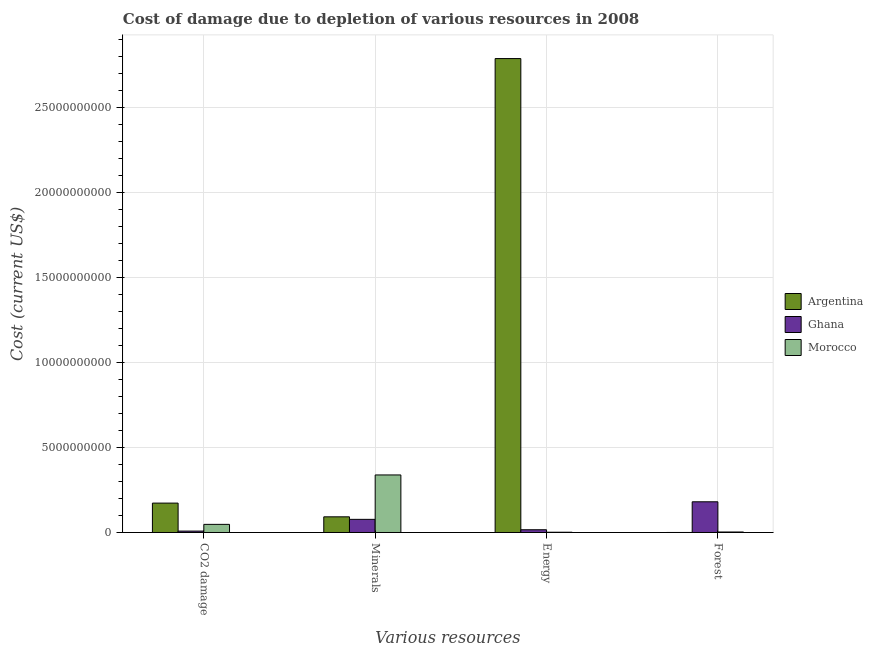How many different coloured bars are there?
Your answer should be very brief. 3. How many groups of bars are there?
Give a very brief answer. 4. Are the number of bars per tick equal to the number of legend labels?
Provide a short and direct response. Yes. How many bars are there on the 4th tick from the right?
Your answer should be very brief. 3. What is the label of the 2nd group of bars from the left?
Offer a terse response. Minerals. What is the cost of damage due to depletion of forests in Ghana?
Provide a short and direct response. 1.81e+09. Across all countries, what is the maximum cost of damage due to depletion of minerals?
Ensure brevity in your answer.  3.38e+09. Across all countries, what is the minimum cost of damage due to depletion of coal?
Ensure brevity in your answer.  8.25e+07. In which country was the cost of damage due to depletion of minerals maximum?
Keep it short and to the point. Morocco. In which country was the cost of damage due to depletion of energy minimum?
Make the answer very short. Morocco. What is the total cost of damage due to depletion of forests in the graph?
Provide a succinct answer. 1.84e+09. What is the difference between the cost of damage due to depletion of coal in Morocco and that in Ghana?
Your response must be concise. 3.95e+08. What is the difference between the cost of damage due to depletion of forests in Morocco and the cost of damage due to depletion of minerals in Ghana?
Your answer should be compact. -7.43e+08. What is the average cost of damage due to depletion of forests per country?
Make the answer very short. 6.12e+08. What is the difference between the cost of damage due to depletion of forests and cost of damage due to depletion of minerals in Morocco?
Give a very brief answer. -3.36e+09. In how many countries, is the cost of damage due to depletion of coal greater than 4000000000 US$?
Your answer should be compact. 0. What is the ratio of the cost of damage due to depletion of coal in Ghana to that in Argentina?
Offer a very short reply. 0.05. Is the cost of damage due to depletion of energy in Argentina less than that in Ghana?
Ensure brevity in your answer.  No. What is the difference between the highest and the second highest cost of damage due to depletion of coal?
Provide a short and direct response. 1.25e+09. What is the difference between the highest and the lowest cost of damage due to depletion of forests?
Provide a short and direct response. 1.81e+09. In how many countries, is the cost of damage due to depletion of energy greater than the average cost of damage due to depletion of energy taken over all countries?
Offer a terse response. 1. Is the sum of the cost of damage due to depletion of coal in Morocco and Argentina greater than the maximum cost of damage due to depletion of forests across all countries?
Offer a very short reply. Yes. What does the 3rd bar from the right in Energy represents?
Give a very brief answer. Argentina. Are all the bars in the graph horizontal?
Your answer should be compact. No. What is the difference between two consecutive major ticks on the Y-axis?
Provide a short and direct response. 5.00e+09. Does the graph contain any zero values?
Your answer should be compact. No. How many legend labels are there?
Ensure brevity in your answer.  3. What is the title of the graph?
Provide a succinct answer. Cost of damage due to depletion of various resources in 2008 . What is the label or title of the X-axis?
Your answer should be compact. Various resources. What is the label or title of the Y-axis?
Offer a very short reply. Cost (current US$). What is the Cost (current US$) of Argentina in CO2 damage?
Your answer should be very brief. 1.73e+09. What is the Cost (current US$) of Ghana in CO2 damage?
Make the answer very short. 8.25e+07. What is the Cost (current US$) of Morocco in CO2 damage?
Offer a very short reply. 4.77e+08. What is the Cost (current US$) of Argentina in Minerals?
Provide a succinct answer. 9.21e+08. What is the Cost (current US$) of Ghana in Minerals?
Provide a short and direct response. 7.72e+08. What is the Cost (current US$) in Morocco in Minerals?
Your answer should be compact. 3.38e+09. What is the Cost (current US$) of Argentina in Energy?
Offer a very short reply. 2.79e+1. What is the Cost (current US$) of Ghana in Energy?
Your answer should be very brief. 1.61e+08. What is the Cost (current US$) in Morocco in Energy?
Provide a short and direct response. 1.57e+07. What is the Cost (current US$) in Argentina in Forest?
Ensure brevity in your answer.  3.09e+05. What is the Cost (current US$) in Ghana in Forest?
Keep it short and to the point. 1.81e+09. What is the Cost (current US$) in Morocco in Forest?
Provide a short and direct response. 2.91e+07. Across all Various resources, what is the maximum Cost (current US$) of Argentina?
Your answer should be very brief. 2.79e+1. Across all Various resources, what is the maximum Cost (current US$) in Ghana?
Your answer should be very brief. 1.81e+09. Across all Various resources, what is the maximum Cost (current US$) of Morocco?
Make the answer very short. 3.38e+09. Across all Various resources, what is the minimum Cost (current US$) in Argentina?
Your answer should be compact. 3.09e+05. Across all Various resources, what is the minimum Cost (current US$) in Ghana?
Provide a succinct answer. 8.25e+07. Across all Various resources, what is the minimum Cost (current US$) in Morocco?
Make the answer very short. 1.57e+07. What is the total Cost (current US$) in Argentina in the graph?
Provide a succinct answer. 3.05e+1. What is the total Cost (current US$) in Ghana in the graph?
Provide a short and direct response. 2.82e+09. What is the total Cost (current US$) of Morocco in the graph?
Provide a succinct answer. 3.91e+09. What is the difference between the Cost (current US$) in Argentina in CO2 damage and that in Minerals?
Offer a very short reply. 8.07e+08. What is the difference between the Cost (current US$) in Ghana in CO2 damage and that in Minerals?
Make the answer very short. -6.90e+08. What is the difference between the Cost (current US$) of Morocco in CO2 damage and that in Minerals?
Keep it short and to the point. -2.91e+09. What is the difference between the Cost (current US$) in Argentina in CO2 damage and that in Energy?
Ensure brevity in your answer.  -2.62e+1. What is the difference between the Cost (current US$) of Ghana in CO2 damage and that in Energy?
Ensure brevity in your answer.  -7.87e+07. What is the difference between the Cost (current US$) in Morocco in CO2 damage and that in Energy?
Provide a short and direct response. 4.62e+08. What is the difference between the Cost (current US$) in Argentina in CO2 damage and that in Forest?
Offer a very short reply. 1.73e+09. What is the difference between the Cost (current US$) in Ghana in CO2 damage and that in Forest?
Your response must be concise. -1.72e+09. What is the difference between the Cost (current US$) in Morocco in CO2 damage and that in Forest?
Your response must be concise. 4.48e+08. What is the difference between the Cost (current US$) in Argentina in Minerals and that in Energy?
Keep it short and to the point. -2.70e+1. What is the difference between the Cost (current US$) in Ghana in Minerals and that in Energy?
Keep it short and to the point. 6.11e+08. What is the difference between the Cost (current US$) of Morocco in Minerals and that in Energy?
Your answer should be compact. 3.37e+09. What is the difference between the Cost (current US$) in Argentina in Minerals and that in Forest?
Provide a short and direct response. 9.21e+08. What is the difference between the Cost (current US$) in Ghana in Minerals and that in Forest?
Your response must be concise. -1.03e+09. What is the difference between the Cost (current US$) in Morocco in Minerals and that in Forest?
Your answer should be very brief. 3.36e+09. What is the difference between the Cost (current US$) in Argentina in Energy and that in Forest?
Offer a terse response. 2.79e+1. What is the difference between the Cost (current US$) in Ghana in Energy and that in Forest?
Ensure brevity in your answer.  -1.64e+09. What is the difference between the Cost (current US$) of Morocco in Energy and that in Forest?
Give a very brief answer. -1.34e+07. What is the difference between the Cost (current US$) in Argentina in CO2 damage and the Cost (current US$) in Ghana in Minerals?
Make the answer very short. 9.56e+08. What is the difference between the Cost (current US$) in Argentina in CO2 damage and the Cost (current US$) in Morocco in Minerals?
Offer a very short reply. -1.66e+09. What is the difference between the Cost (current US$) in Ghana in CO2 damage and the Cost (current US$) in Morocco in Minerals?
Provide a short and direct response. -3.30e+09. What is the difference between the Cost (current US$) in Argentina in CO2 damage and the Cost (current US$) in Ghana in Energy?
Provide a short and direct response. 1.57e+09. What is the difference between the Cost (current US$) in Argentina in CO2 damage and the Cost (current US$) in Morocco in Energy?
Your answer should be very brief. 1.71e+09. What is the difference between the Cost (current US$) of Ghana in CO2 damage and the Cost (current US$) of Morocco in Energy?
Provide a succinct answer. 6.67e+07. What is the difference between the Cost (current US$) of Argentina in CO2 damage and the Cost (current US$) of Ghana in Forest?
Offer a terse response. -7.68e+07. What is the difference between the Cost (current US$) of Argentina in CO2 damage and the Cost (current US$) of Morocco in Forest?
Your answer should be compact. 1.70e+09. What is the difference between the Cost (current US$) of Ghana in CO2 damage and the Cost (current US$) of Morocco in Forest?
Offer a terse response. 5.33e+07. What is the difference between the Cost (current US$) in Argentina in Minerals and the Cost (current US$) in Ghana in Energy?
Your answer should be very brief. 7.60e+08. What is the difference between the Cost (current US$) of Argentina in Minerals and the Cost (current US$) of Morocco in Energy?
Offer a terse response. 9.06e+08. What is the difference between the Cost (current US$) of Ghana in Minerals and the Cost (current US$) of Morocco in Energy?
Your answer should be compact. 7.57e+08. What is the difference between the Cost (current US$) of Argentina in Minerals and the Cost (current US$) of Ghana in Forest?
Give a very brief answer. -8.84e+08. What is the difference between the Cost (current US$) in Argentina in Minerals and the Cost (current US$) in Morocco in Forest?
Ensure brevity in your answer.  8.92e+08. What is the difference between the Cost (current US$) in Ghana in Minerals and the Cost (current US$) in Morocco in Forest?
Make the answer very short. 7.43e+08. What is the difference between the Cost (current US$) of Argentina in Energy and the Cost (current US$) of Ghana in Forest?
Your response must be concise. 2.61e+1. What is the difference between the Cost (current US$) in Argentina in Energy and the Cost (current US$) in Morocco in Forest?
Your answer should be very brief. 2.79e+1. What is the difference between the Cost (current US$) of Ghana in Energy and the Cost (current US$) of Morocco in Forest?
Your response must be concise. 1.32e+08. What is the average Cost (current US$) in Argentina per Various resources?
Provide a succinct answer. 7.63e+09. What is the average Cost (current US$) of Ghana per Various resources?
Ensure brevity in your answer.  7.05e+08. What is the average Cost (current US$) in Morocco per Various resources?
Give a very brief answer. 9.77e+08. What is the difference between the Cost (current US$) in Argentina and Cost (current US$) in Ghana in CO2 damage?
Ensure brevity in your answer.  1.65e+09. What is the difference between the Cost (current US$) in Argentina and Cost (current US$) in Morocco in CO2 damage?
Give a very brief answer. 1.25e+09. What is the difference between the Cost (current US$) in Ghana and Cost (current US$) in Morocco in CO2 damage?
Provide a short and direct response. -3.95e+08. What is the difference between the Cost (current US$) of Argentina and Cost (current US$) of Ghana in Minerals?
Offer a terse response. 1.49e+08. What is the difference between the Cost (current US$) in Argentina and Cost (current US$) in Morocco in Minerals?
Your answer should be compact. -2.46e+09. What is the difference between the Cost (current US$) in Ghana and Cost (current US$) in Morocco in Minerals?
Provide a succinct answer. -2.61e+09. What is the difference between the Cost (current US$) of Argentina and Cost (current US$) of Ghana in Energy?
Offer a very short reply. 2.77e+1. What is the difference between the Cost (current US$) of Argentina and Cost (current US$) of Morocco in Energy?
Your answer should be very brief. 2.79e+1. What is the difference between the Cost (current US$) of Ghana and Cost (current US$) of Morocco in Energy?
Provide a succinct answer. 1.45e+08. What is the difference between the Cost (current US$) in Argentina and Cost (current US$) in Ghana in Forest?
Provide a succinct answer. -1.81e+09. What is the difference between the Cost (current US$) in Argentina and Cost (current US$) in Morocco in Forest?
Ensure brevity in your answer.  -2.88e+07. What is the difference between the Cost (current US$) of Ghana and Cost (current US$) of Morocco in Forest?
Provide a short and direct response. 1.78e+09. What is the ratio of the Cost (current US$) of Argentina in CO2 damage to that in Minerals?
Keep it short and to the point. 1.88. What is the ratio of the Cost (current US$) in Ghana in CO2 damage to that in Minerals?
Provide a succinct answer. 0.11. What is the ratio of the Cost (current US$) of Morocco in CO2 damage to that in Minerals?
Ensure brevity in your answer.  0.14. What is the ratio of the Cost (current US$) of Argentina in CO2 damage to that in Energy?
Offer a very short reply. 0.06. What is the ratio of the Cost (current US$) of Ghana in CO2 damage to that in Energy?
Keep it short and to the point. 0.51. What is the ratio of the Cost (current US$) of Morocco in CO2 damage to that in Energy?
Ensure brevity in your answer.  30.33. What is the ratio of the Cost (current US$) of Argentina in CO2 damage to that in Forest?
Give a very brief answer. 5601.17. What is the ratio of the Cost (current US$) of Ghana in CO2 damage to that in Forest?
Offer a terse response. 0.05. What is the ratio of the Cost (current US$) of Morocco in CO2 damage to that in Forest?
Offer a very short reply. 16.4. What is the ratio of the Cost (current US$) in Argentina in Minerals to that in Energy?
Offer a very short reply. 0.03. What is the ratio of the Cost (current US$) of Ghana in Minerals to that in Energy?
Your answer should be very brief. 4.79. What is the ratio of the Cost (current US$) in Morocco in Minerals to that in Energy?
Provide a succinct answer. 215.08. What is the ratio of the Cost (current US$) in Argentina in Minerals to that in Forest?
Offer a very short reply. 2984.92. What is the ratio of the Cost (current US$) in Ghana in Minerals to that in Forest?
Offer a very short reply. 0.43. What is the ratio of the Cost (current US$) in Morocco in Minerals to that in Forest?
Make the answer very short. 116.26. What is the ratio of the Cost (current US$) of Argentina in Energy to that in Forest?
Make the answer very short. 9.03e+04. What is the ratio of the Cost (current US$) of Ghana in Energy to that in Forest?
Keep it short and to the point. 0.09. What is the ratio of the Cost (current US$) in Morocco in Energy to that in Forest?
Ensure brevity in your answer.  0.54. What is the difference between the highest and the second highest Cost (current US$) of Argentina?
Provide a succinct answer. 2.62e+1. What is the difference between the highest and the second highest Cost (current US$) of Ghana?
Give a very brief answer. 1.03e+09. What is the difference between the highest and the second highest Cost (current US$) of Morocco?
Your answer should be very brief. 2.91e+09. What is the difference between the highest and the lowest Cost (current US$) in Argentina?
Offer a very short reply. 2.79e+1. What is the difference between the highest and the lowest Cost (current US$) of Ghana?
Ensure brevity in your answer.  1.72e+09. What is the difference between the highest and the lowest Cost (current US$) in Morocco?
Make the answer very short. 3.37e+09. 